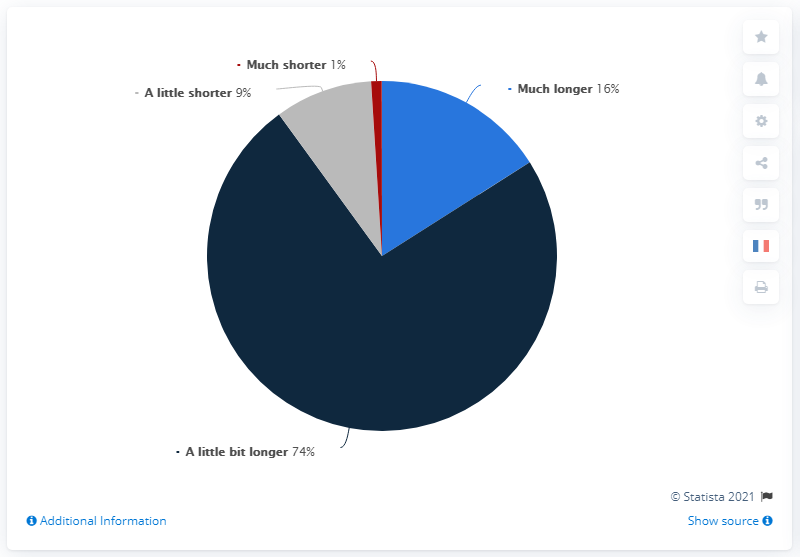Point out several critical features in this image. It is expected that the responses that suggest a shorter duration range from 10 to 20 will be added up to a total of 10. The most popular response is a little bit longer. 